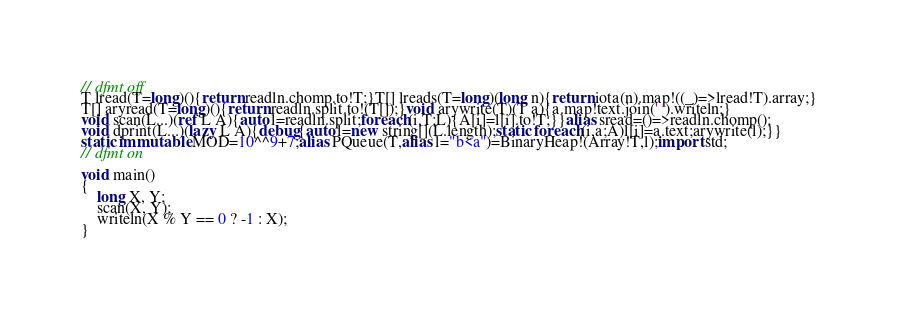Convert code to text. <code><loc_0><loc_0><loc_500><loc_500><_D_>// dfmt off
T lread(T=long)(){return readln.chomp.to!T;}T[] lreads(T=long)(long n){return iota(n).map!((_)=>lread!T).array;}
T[] aryread(T=long)(){return readln.split.to!(T[]);}void arywrite(T)(T a){a.map!text.join(' ').writeln;}
void scan(L...)(ref L A){auto l=readln.split;foreach(i,T;L){A[i]=l[i].to!T;}}alias sread=()=>readln.chomp();
void dprint(L...)(lazy L A){debug{auto l=new string[](L.length);static foreach(i,a;A)l[i]=a.text;arywrite(l);}}
static immutable MOD=10^^9+7;alias PQueue(T,alias l="b<a")=BinaryHeap!(Array!T,l);import std;
// dfmt on

void main()
{
    long X, Y;
    scan(X, Y);
    writeln(X % Y == 0 ? -1 : X);
}
</code> 